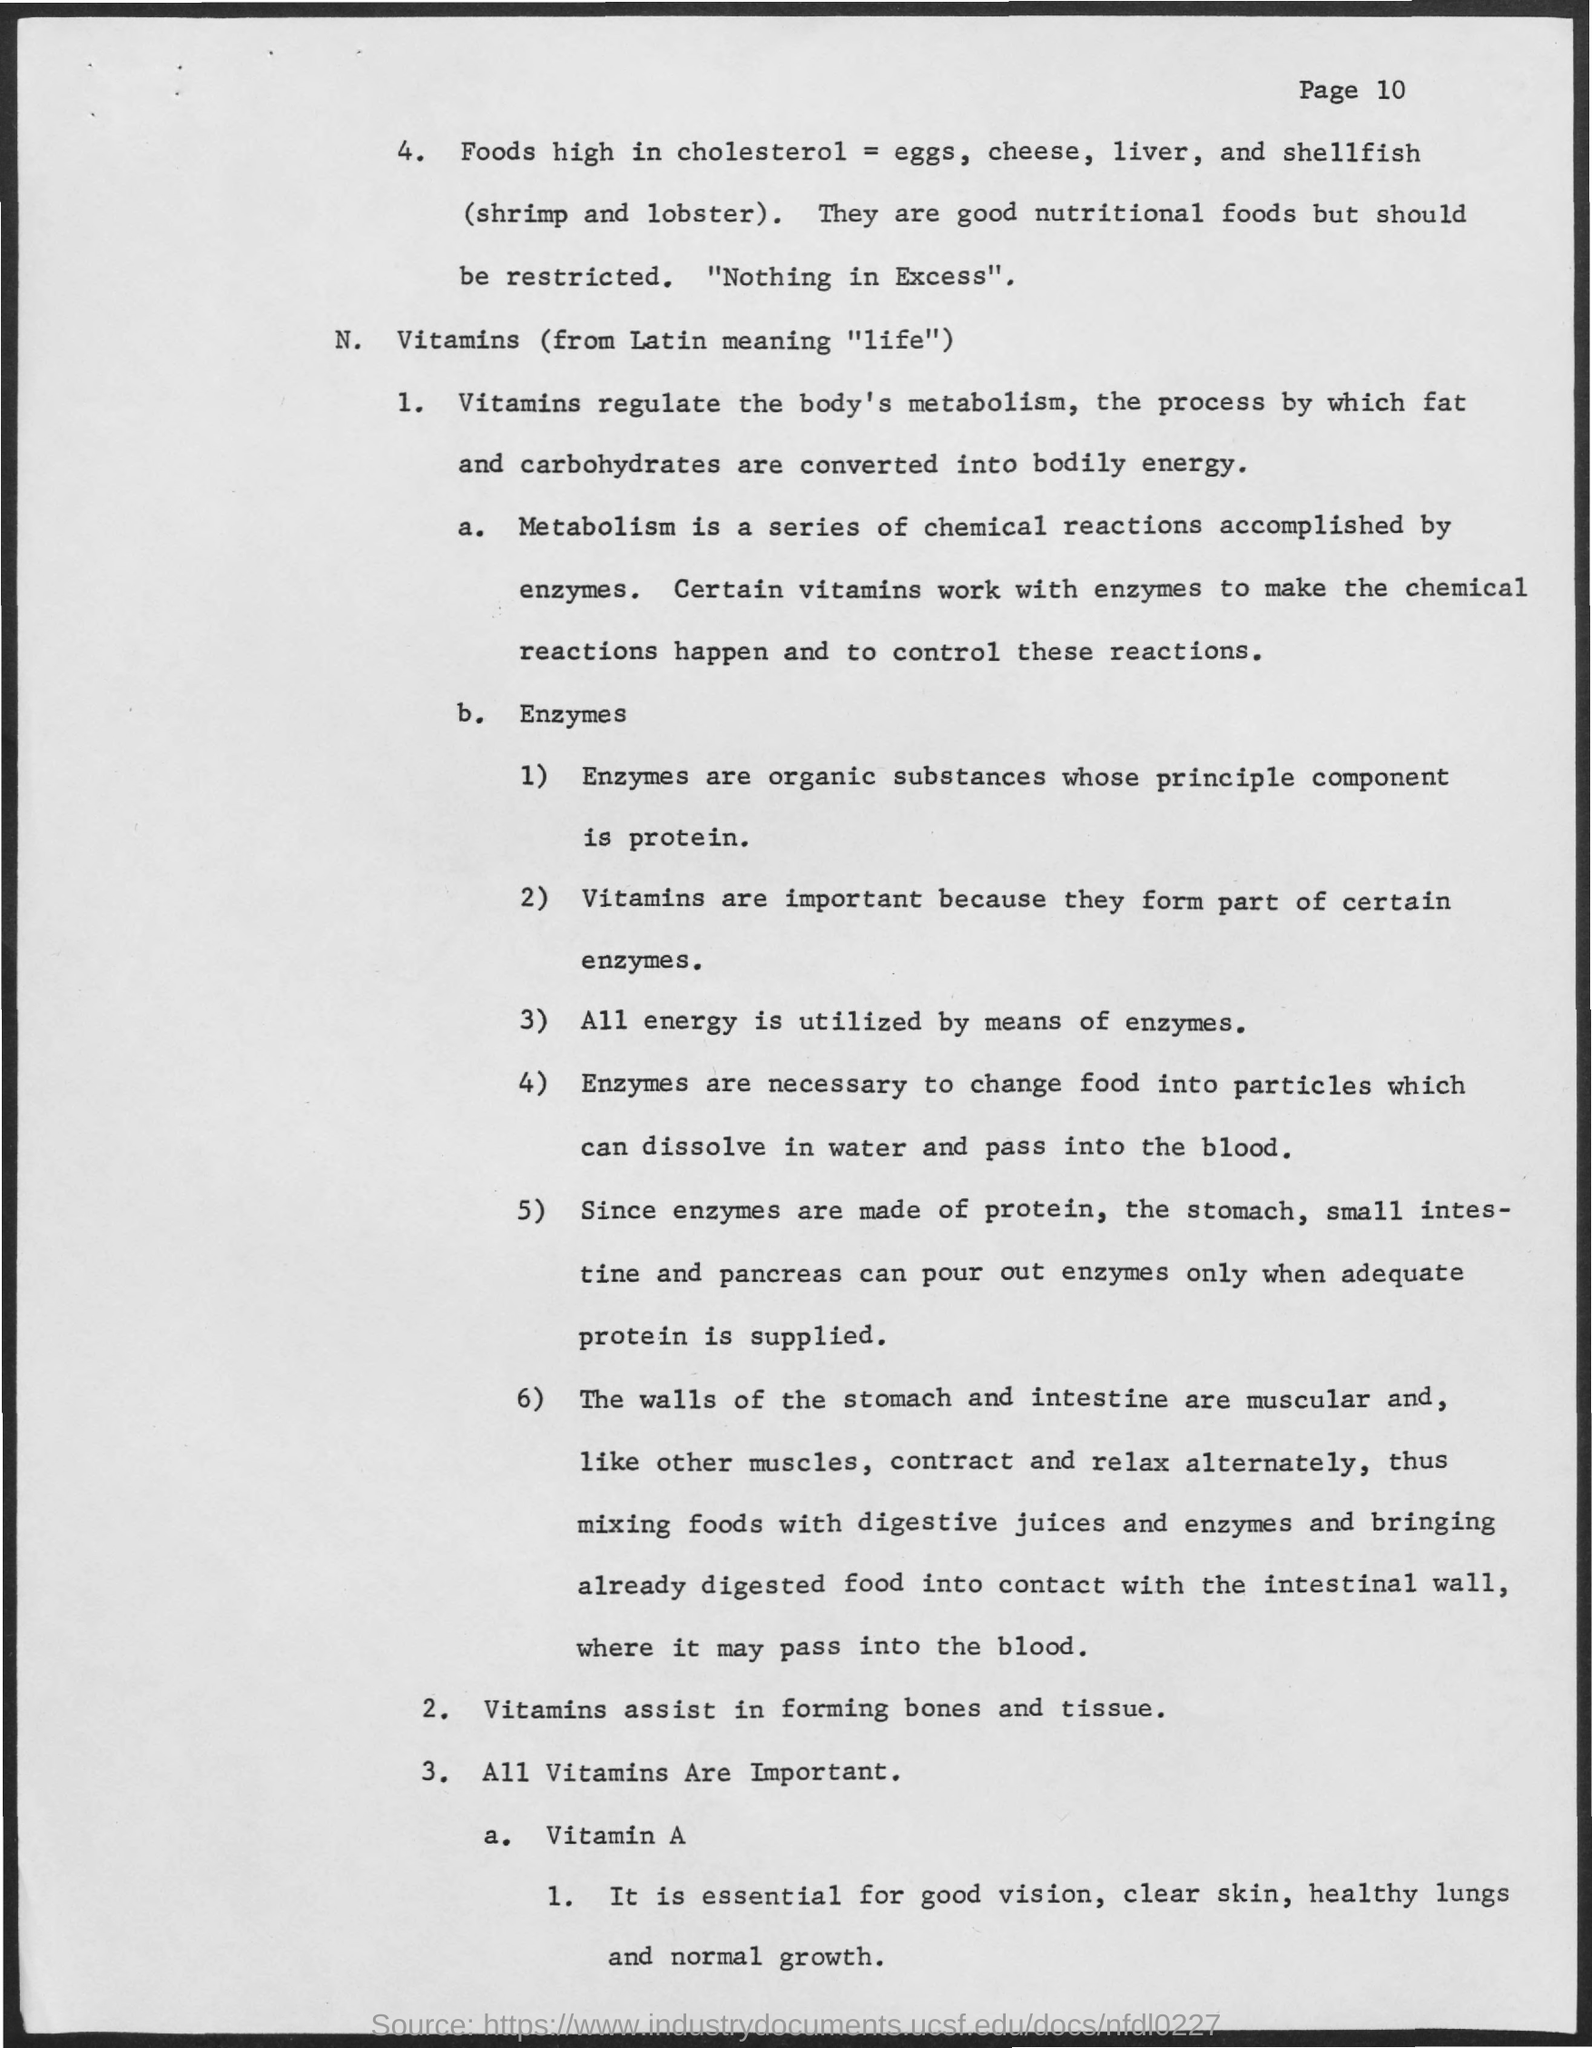What is the process where fats and carbohydrates are converted to energy?
Provide a short and direct response. METABOLISM. What is required for assisting  bone and tissue formation?
Your response must be concise. VITAMINS. 